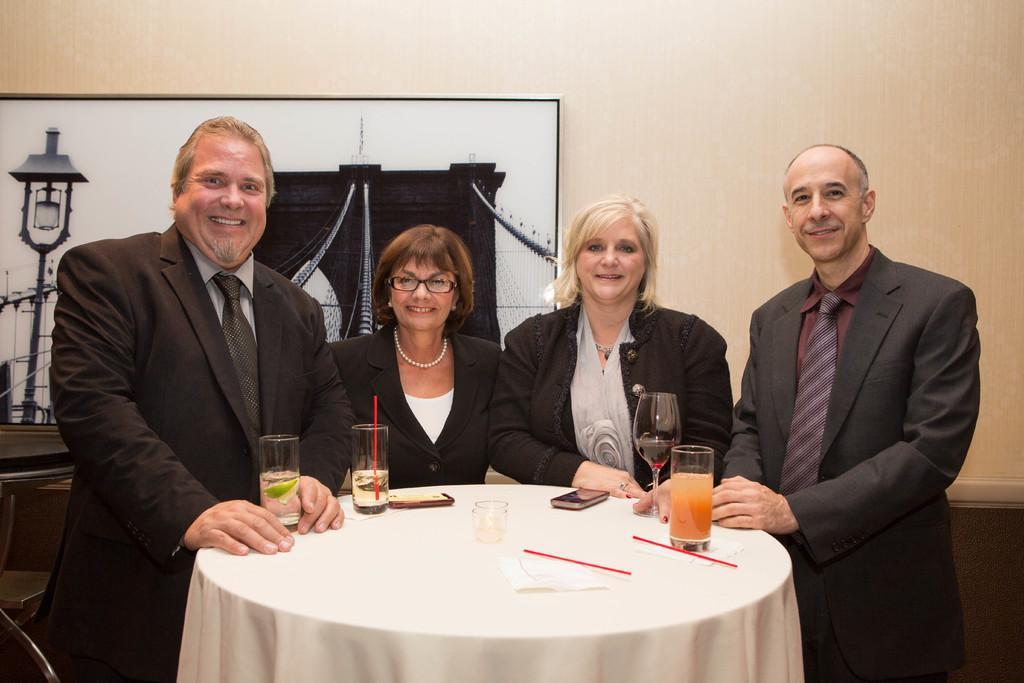Please provide a concise description of this image. There is a table in the middle of the image which is covered by a white color cloth. On that table there are some glasses and there are some peoples standing around the table, In the background there is a brown color wall on that wall there is a white color poster and black color desk. 